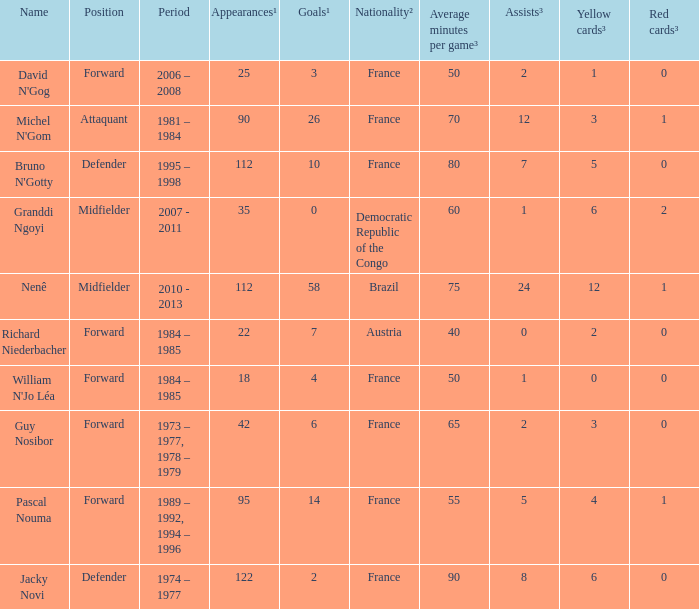How many players are from the country of Brazil? 1.0. 